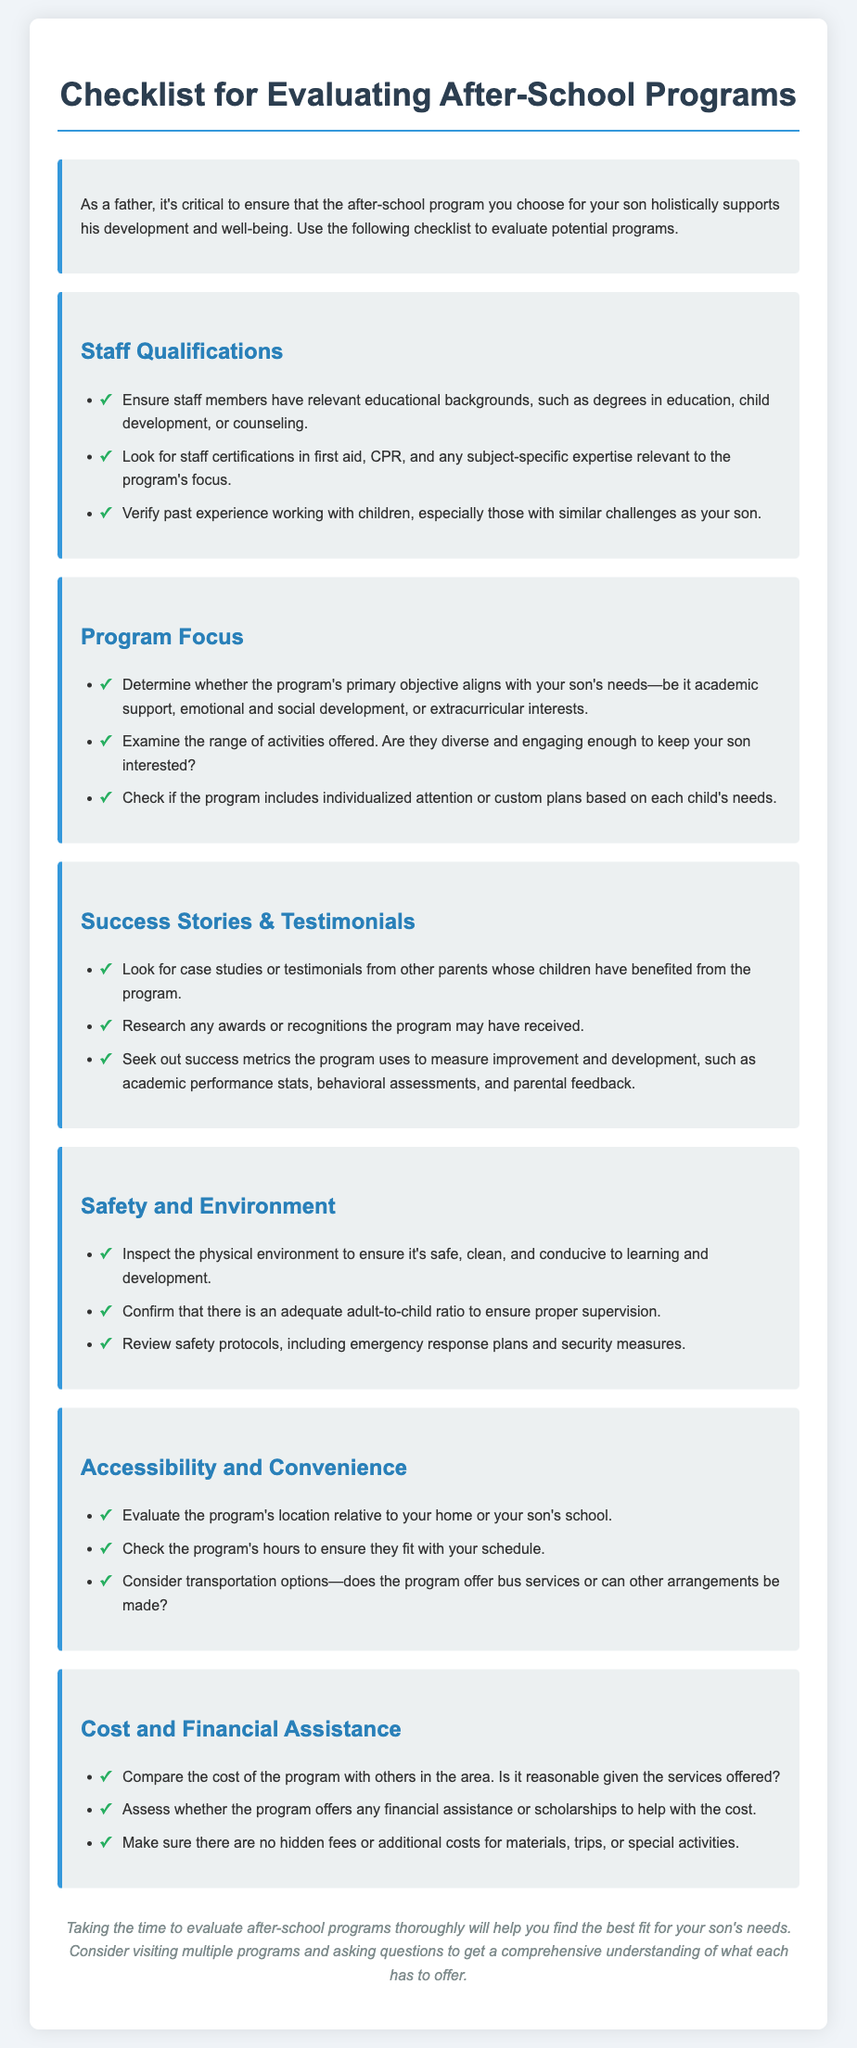What should staff members have in terms of education? The document suggests that staff members should have relevant educational backgrounds, such as degrees in education, child development, or counseling.
Answer: degrees in education, child development, or counseling What is a key factor in the program focus? The program's primary objective should align with the child's needs, such as academic support or emotional development.
Answer: align with your son's needs What safety aspect should be inspected? The physical environment should be safe, clean, and conducive to learning and development, as stated in the safety and environment section.
Answer: safe, clean, and conducive How can you verify if a program has been successful? Success stories and testimonials from other parents can help verify if a program has benefited children in the past.
Answer: testimonials What financial assistance options should be considered? The document highlights assessing whether the program offers any financial assistance or scholarships to help with costs.
Answer: financial assistance or scholarships What is an important staff qualification mentioned? The document mentions that staff certifications in first aid, CPR, and subject-specific expertise are important qualifications.
Answer: first aid, CPR, subject-specific expertise How should the program's cost be evaluated? The cost should be compared with others in the area to assess if it is reasonable for the services offered.
Answer: compare with others in the area What is an important aspect of the program’s accessibility? Evaluating the program's hours is crucial to ensure they fit with the parent's schedule.
Answer: program's hours What should be reviewed regarding safety protocols? The document advises that safety protocols should include emergency response plans and security measures.
Answer: emergency response plans and security measures 